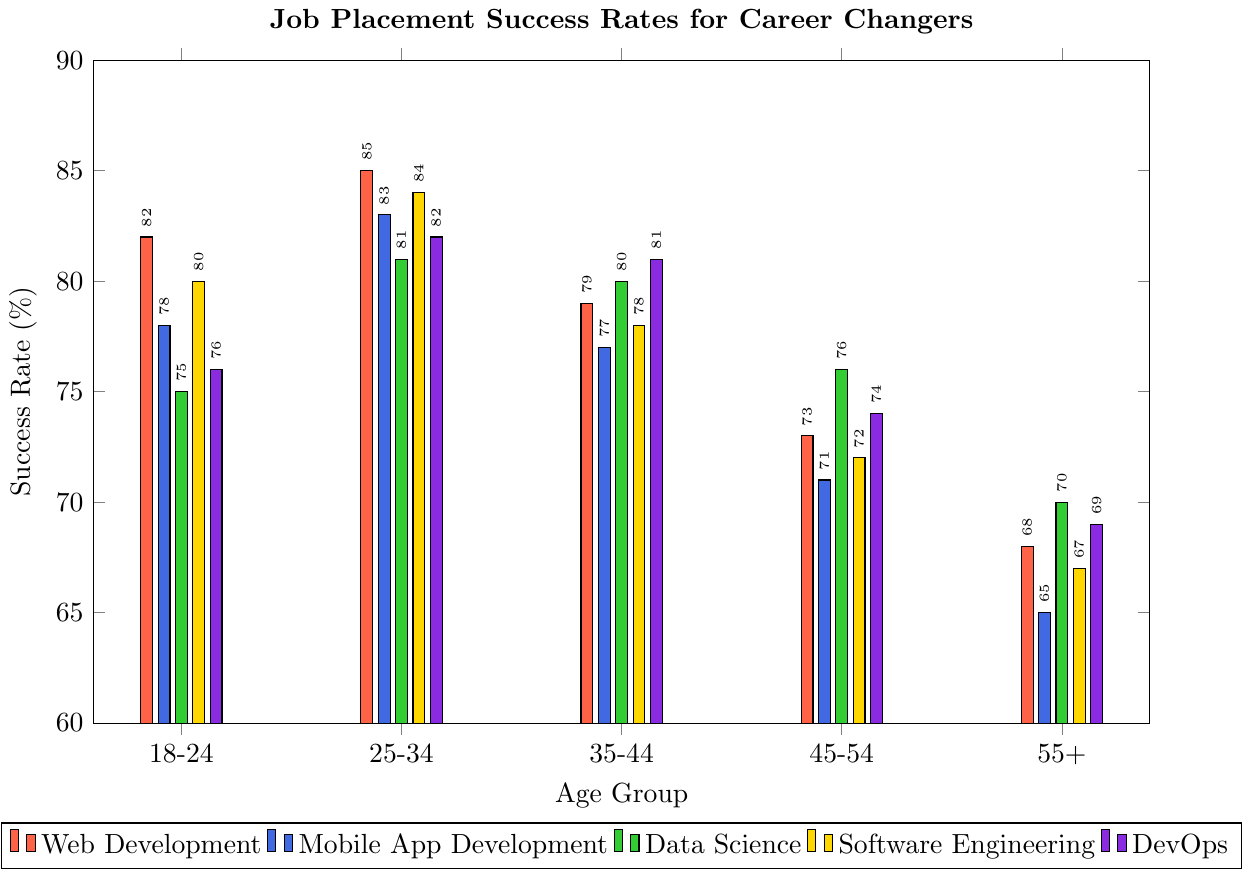What is the success rate for Web Development in the 25-34 age group? Look at the bar for Web Development in the 25-34 age group and note its height. It corresponds to the value 85%.
Answer: 85% Which age group has the highest success rate for Mobile App Development? Compare the heights of the bars representing Mobile App Development across different age groups. The highest bar corresponds to the 25-34 age group.
Answer: 25-34 How much lower is the success rate for DevOps in the 55+ age group compared to the 18-24 age group? Subtract the success rate for DevOps in the 55+ age group (69) from the success rate in the 18-24 age group (76). Calculation: 76 - 69 = 7.
Answer: 7% Among all age groups, which field has the highest job placement success rate? Identify the highest bar in the entire chart. The highest bar is for Web Development in the 25-34 age group, with a 85% success rate.
Answer: Web Development What is the average success rate for Software Engineering across all age groups? Add the success rates for Software Engineering across all age groups and divide by the number of age groups (5). Calculation: (80 + 84 + 78 + 72 + 67) / 5 = 76.2.
Answer: 76.2% Which age group has the lowest success rate for Data Science? Identify the shortest bar representing Data Science across the age groups. The 55+ age group has the shortest bar with a success rate of 70%.
Answer: 55+ Compare the success rates for Web Development and Software Engineering for the 35-44 age group. Which one is higher and by how much? Look at the bars for Web Development (79) and Software Engineering (78) in the 35-44 age group. Web Development is higher by 79 - 78 = 1.
Answer: Web Development, 1% What is the total success rate for Mobile App Development and DevOps in the 45-54 age group? Add the success rates for Mobile App Development (71) and DevOps (74) in the 45-54 age group. Calculation: 71 + 74 = 145.
Answer: 145% Which field has the least variation in job placement success rates across all age groups? Look at the range of success rates for each field across all age groups. Data Science has the smallest range from 70% to 81%, a difference of 11%.
Answer: Data Science 